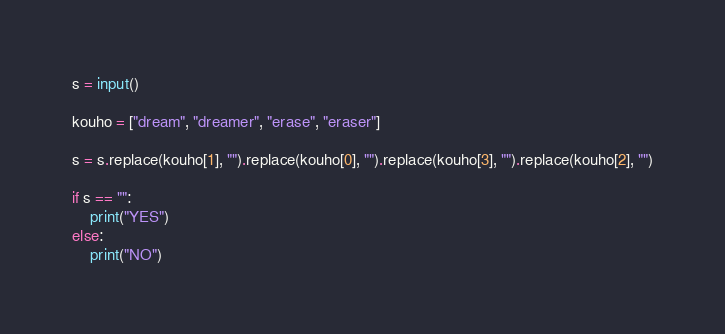<code> <loc_0><loc_0><loc_500><loc_500><_Python_>s = input()

kouho = ["dream", "dreamer", "erase", "eraser"]

s = s.replace(kouho[1], "").replace(kouho[0], "").replace(kouho[3], "").replace(kouho[2], "")

if s == "":
    print("YES")
else:
    print("NO")</code> 